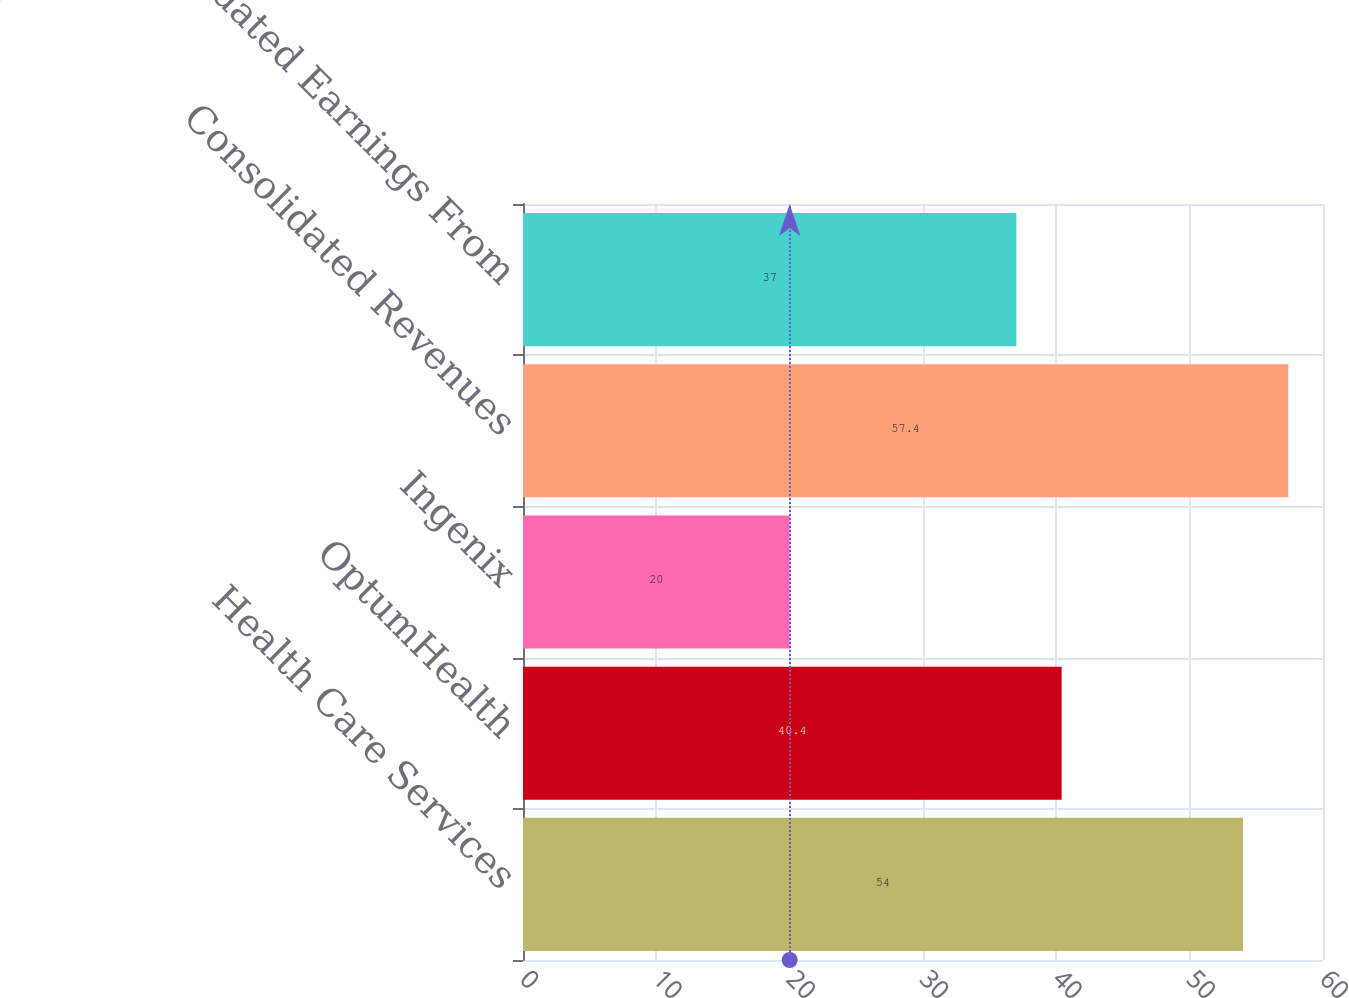<chart> <loc_0><loc_0><loc_500><loc_500><bar_chart><fcel>Health Care Services<fcel>OptumHealth<fcel>Ingenix<fcel>Consolidated Revenues<fcel>Consolidated Earnings From<nl><fcel>54<fcel>40.4<fcel>20<fcel>57.4<fcel>37<nl></chart> 